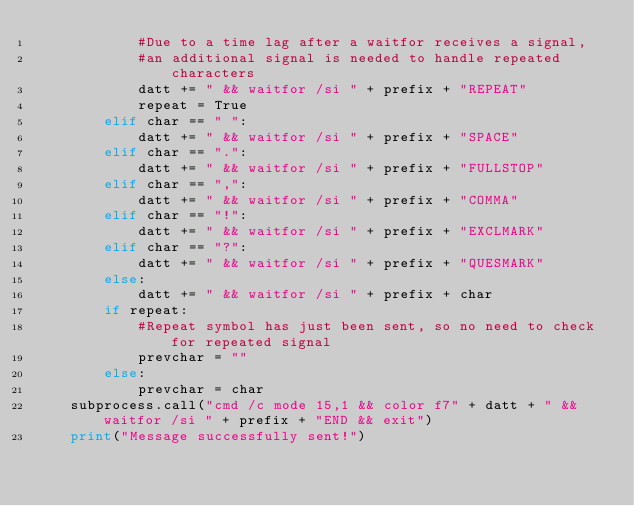<code> <loc_0><loc_0><loc_500><loc_500><_Python_>            #Due to a time lag after a waitfor receives a signal,
            #an additional signal is needed to handle repeated characters
            datt += " && waitfor /si " + prefix + "REPEAT"
            repeat = True
        elif char == " ":
            datt += " && waitfor /si " + prefix + "SPACE"
        elif char == ".":
            datt += " && waitfor /si " + prefix + "FULLSTOP"
        elif char == ",":
            datt += " && waitfor /si " + prefix + "COMMA"
        elif char == "!":
            datt += " && waitfor /si " + prefix + "EXCLMARK"
        elif char == "?":
            datt += " && waitfor /si " + prefix + "QUESMARK"
        else:
            datt += " && waitfor /si " + prefix + char
        if repeat:
            #Repeat symbol has just been sent, so no need to check for repeated signal
            prevchar = ""
        else:
            prevchar = char
    subprocess.call("cmd /c mode 15,1 && color f7" + datt + " && waitfor /si " + prefix + "END && exit")
    print("Message successfully sent!")
</code> 